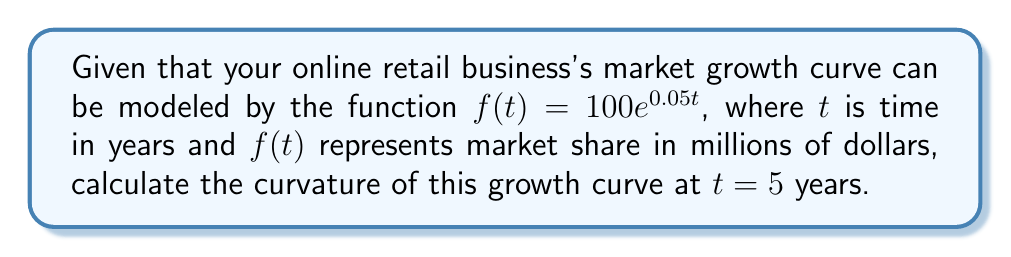Help me with this question. To calculate the curvature of a function $f(t)$ at a given point, we use the formula:

$$\kappa(t) = \frac{|f''(t)|}{(1 + [f'(t)]^2)^{3/2}}$$

Step 1: Calculate $f'(t)$ and $f''(t)$
$f'(t) = 100 \cdot 0.05e^{0.05t} = 5e^{0.05t}$
$f''(t) = 5 \cdot 0.05e^{0.05t} = 0.25e^{0.05t}$

Step 2: Evaluate $f'(t)$ and $f''(t)$ at $t = 5$
$f'(5) = 5e^{0.05 \cdot 5} = 5e^{0.25} \approx 6.4096$
$f''(5) = 0.25e^{0.05 \cdot 5} = 0.25e^{0.25} \approx 0.3205$

Step 3: Calculate $|f''(5)|$
$|f''(5)| = |0.3205| = 0.3205$

Step 4: Calculate $(1 + [f'(5)]^2)^{3/2}$
$(1 + [6.4096]^2)^{3/2} = (1 + 41.0830)^{3/2} = 42.0830^{3/2} \approx 272.8614$

Step 5: Apply the curvature formula
$$\kappa(5) = \frac{0.3205}{272.8614} \approx 0.001174$$
Answer: $\kappa(5) \approx 0.001174$ 